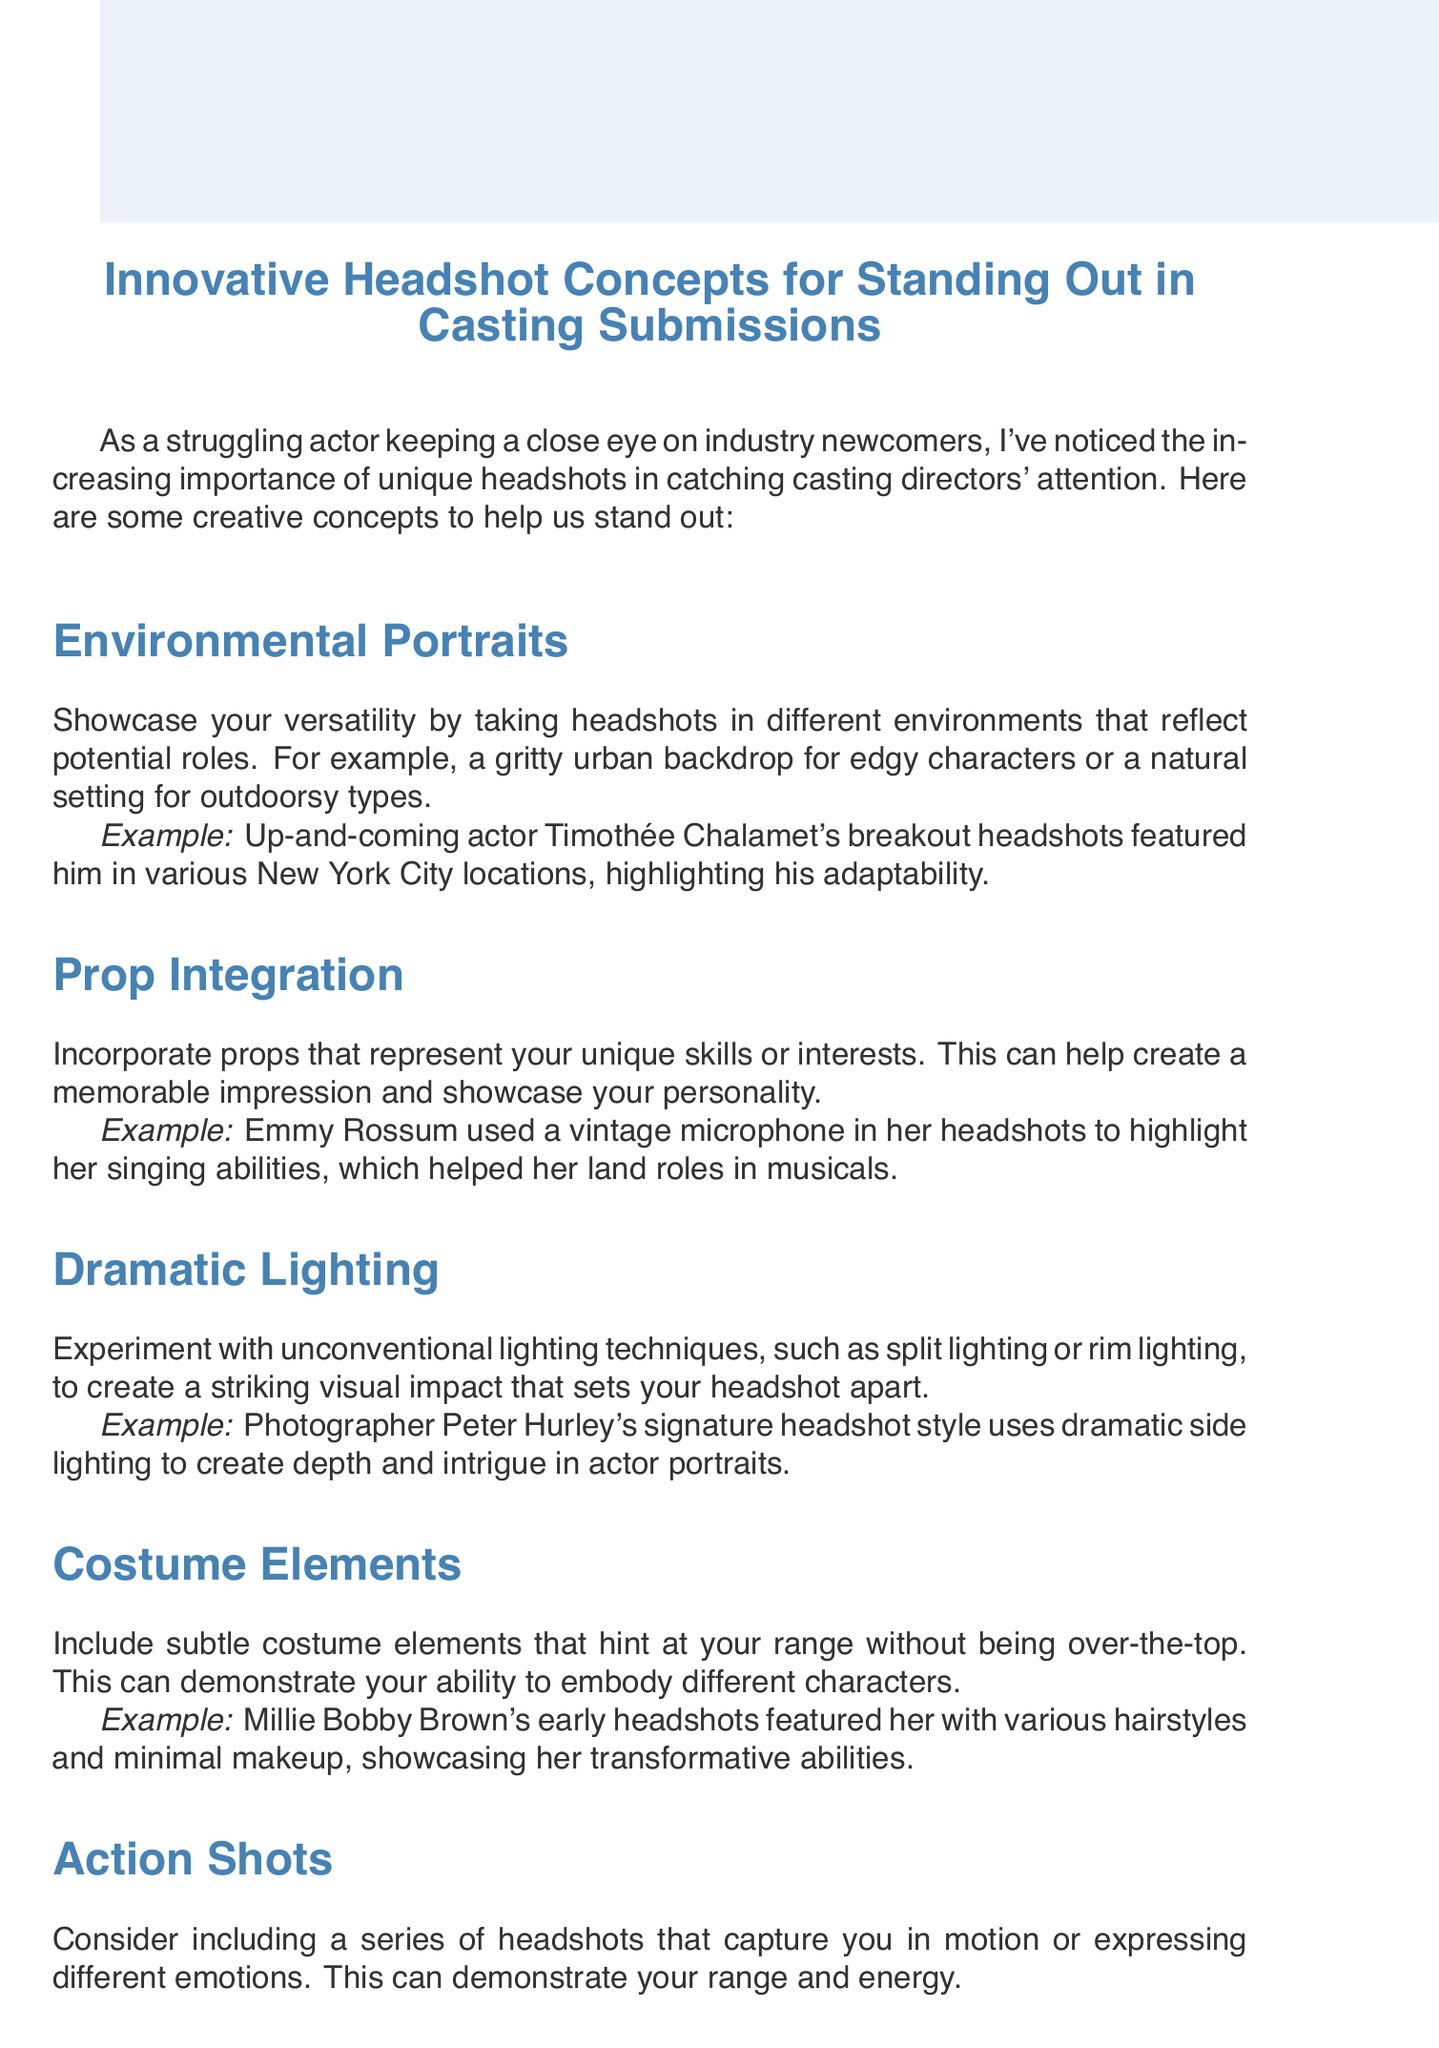What is the title of the memo? The title of the memo is located at the top of the document.
Answer: Innovative Headshot Concepts for Standing Out in Casting Submissions How many headshot concepts are listed? The number of headshot concepts can be counted in the concepts section of the document.
Answer: Five Who is cited as an example for Environmental Portraits? The example is mentioned in the description of the Environmental Portraits concept.
Answer: Timothée Chalamet What type of lighting is suggested in the Dramatic Lighting section? The suggested lighting techniques are described in the Dramatic Lighting section of the document.
Answer: Unconventional Name one consideration mentioned for headshot submissions. The considerations are listed at the end of the memo.
Answer: Update your headshots regularly What does Prop Integration help to showcase? The purpose of incorporating props is found in the description of the Prop Integration concept.
Answer: Personality What style does Peter Hurley use for headshots? The unique styling of Peter Hurley is described in the Dramatic Lighting section.
Answer: Dramatic side lighting Which actress incorporated a vintage microphone in her headshots? The actress is mentioned as an example under the Prop Integration section.
Answer: Emmy Rossum What is emphasized in the conclusion of the memo? The conclusion summarizes the overall message and goals shared in the memo.
Answer: Innovative headshot concepts 